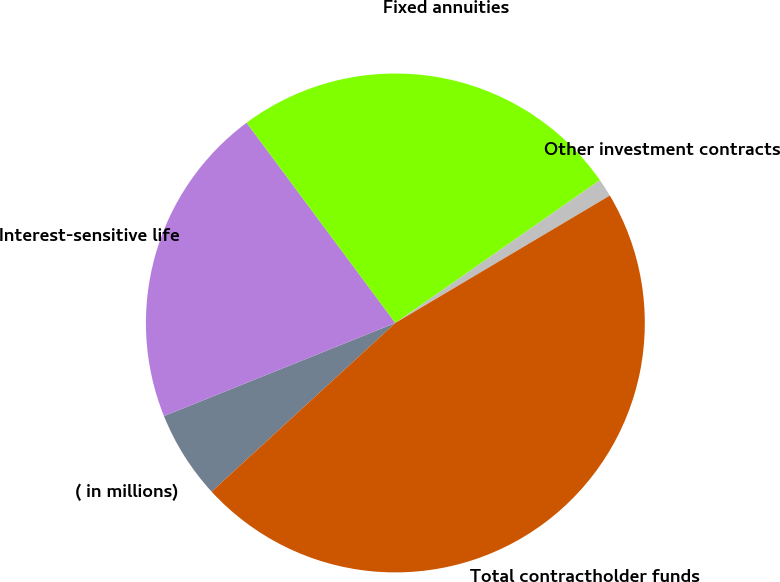Convert chart. <chart><loc_0><loc_0><loc_500><loc_500><pie_chart><fcel>( in millions)<fcel>Interest-sensitive life<fcel>Fixed annuities<fcel>Other investment contracts<fcel>Total contractholder funds<nl><fcel>5.73%<fcel>20.92%<fcel>25.47%<fcel>1.17%<fcel>46.71%<nl></chart> 